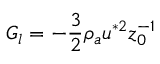<formula> <loc_0><loc_0><loc_500><loc_500>G _ { l } = - \frac { 3 } { 2 } \rho _ { a } u ^ { * 2 } z _ { 0 } ^ { - 1 }</formula> 